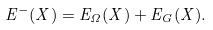<formula> <loc_0><loc_0><loc_500><loc_500>E ^ { - } ( X ) = E _ { \Omega } ( X ) + E _ { G } ( X ) .</formula> 